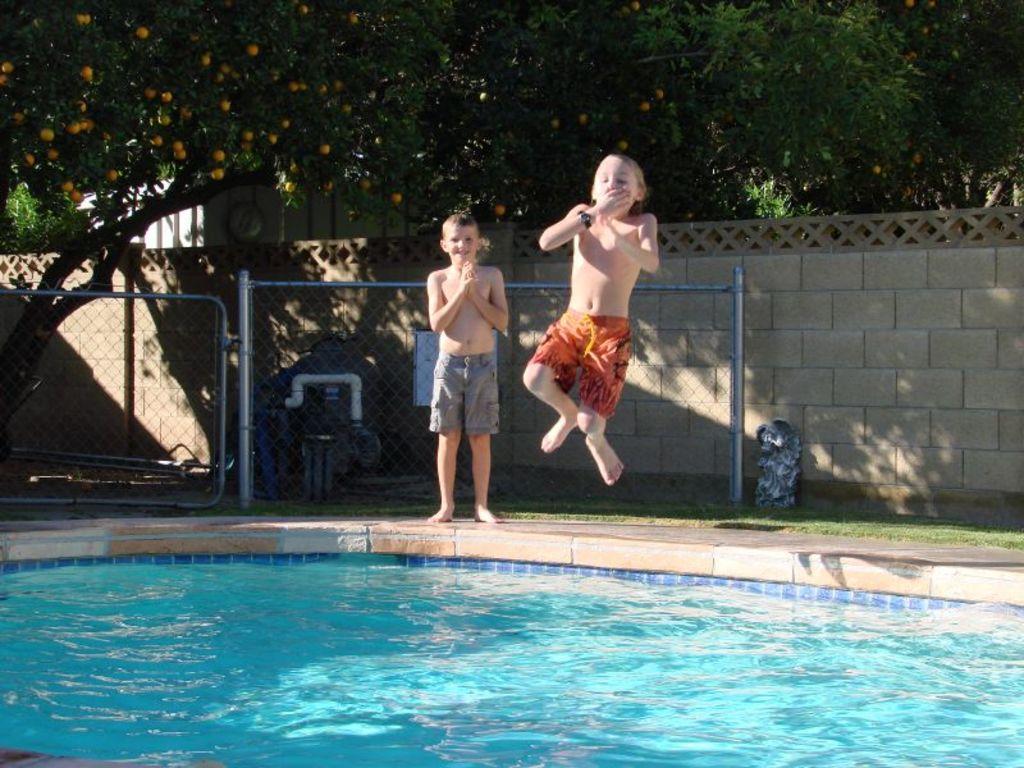Can you describe this image briefly? In this image I can see water and two children in the front. In the background I can see fencing, grass, the wall, few trees and number of fruits on trees. 